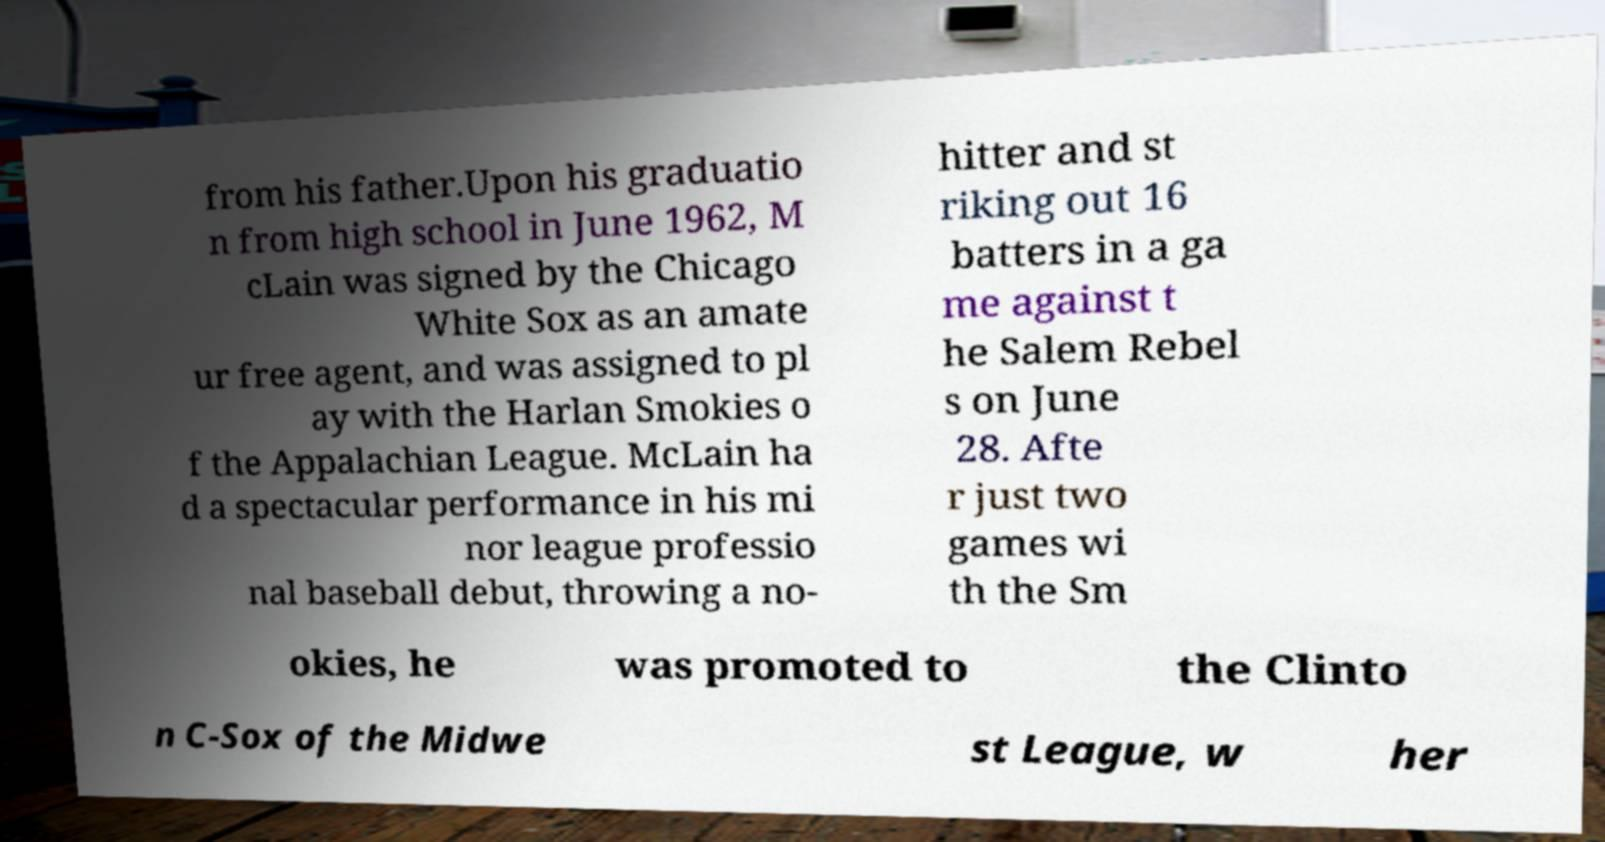For documentation purposes, I need the text within this image transcribed. Could you provide that? from his father.Upon his graduatio n from high school in June 1962, M cLain was signed by the Chicago White Sox as an amate ur free agent, and was assigned to pl ay with the Harlan Smokies o f the Appalachian League. McLain ha d a spectacular performance in his mi nor league professio nal baseball debut, throwing a no- hitter and st riking out 16 batters in a ga me against t he Salem Rebel s on June 28. Afte r just two games wi th the Sm okies, he was promoted to the Clinto n C-Sox of the Midwe st League, w her 